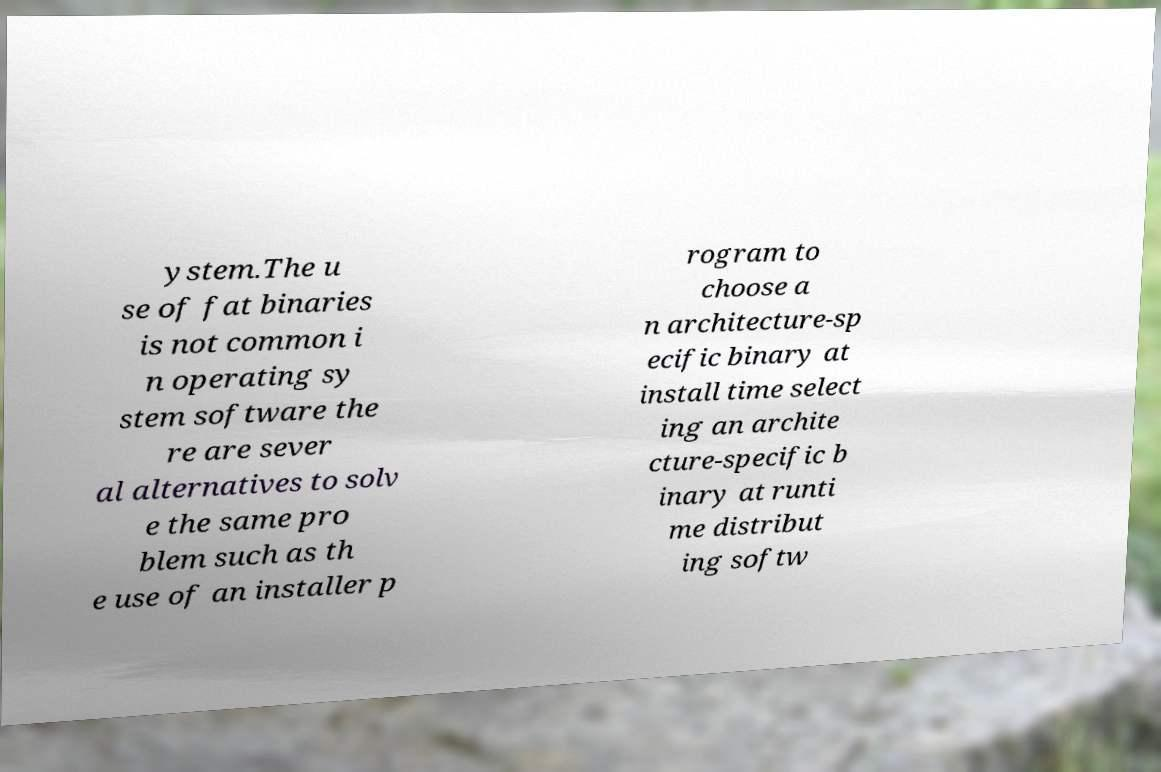Could you extract and type out the text from this image? ystem.The u se of fat binaries is not common i n operating sy stem software the re are sever al alternatives to solv e the same pro blem such as th e use of an installer p rogram to choose a n architecture-sp ecific binary at install time select ing an archite cture-specific b inary at runti me distribut ing softw 